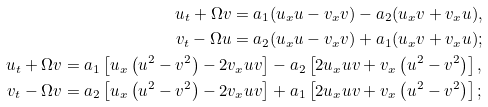Convert formula to latex. <formula><loc_0><loc_0><loc_500><loc_500>u _ { t } + \Omega v = a _ { 1 } ( u _ { x } u - v _ { x } v ) - a _ { 2 } ( u _ { x } v + v _ { x } u ) , \\ v _ { t } - \Omega u = a _ { 2 } ( u _ { x } u - v _ { x } v ) + a _ { 1 } ( u _ { x } v + v _ { x } u ) ; \\ u _ { t } + \Omega v = a _ { 1 } \left [ u _ { x } \left ( u ^ { 2 } - v ^ { 2 } \right ) - 2 v _ { x } u v \right ] - a _ { 2 } \left [ 2 u _ { x } u v + v _ { x } \left ( u ^ { 2 } - v ^ { 2 } \right ) \right ] , \\ v _ { t } - \Omega v = a _ { 2 } \left [ u _ { x } \left ( u ^ { 2 } - v ^ { 2 } \right ) - 2 v _ { x } u v \right ] + a _ { 1 } \left [ 2 u _ { x } u v + v _ { x } \left ( u ^ { 2 } - v ^ { 2 } \right ) \right ] ;</formula> 